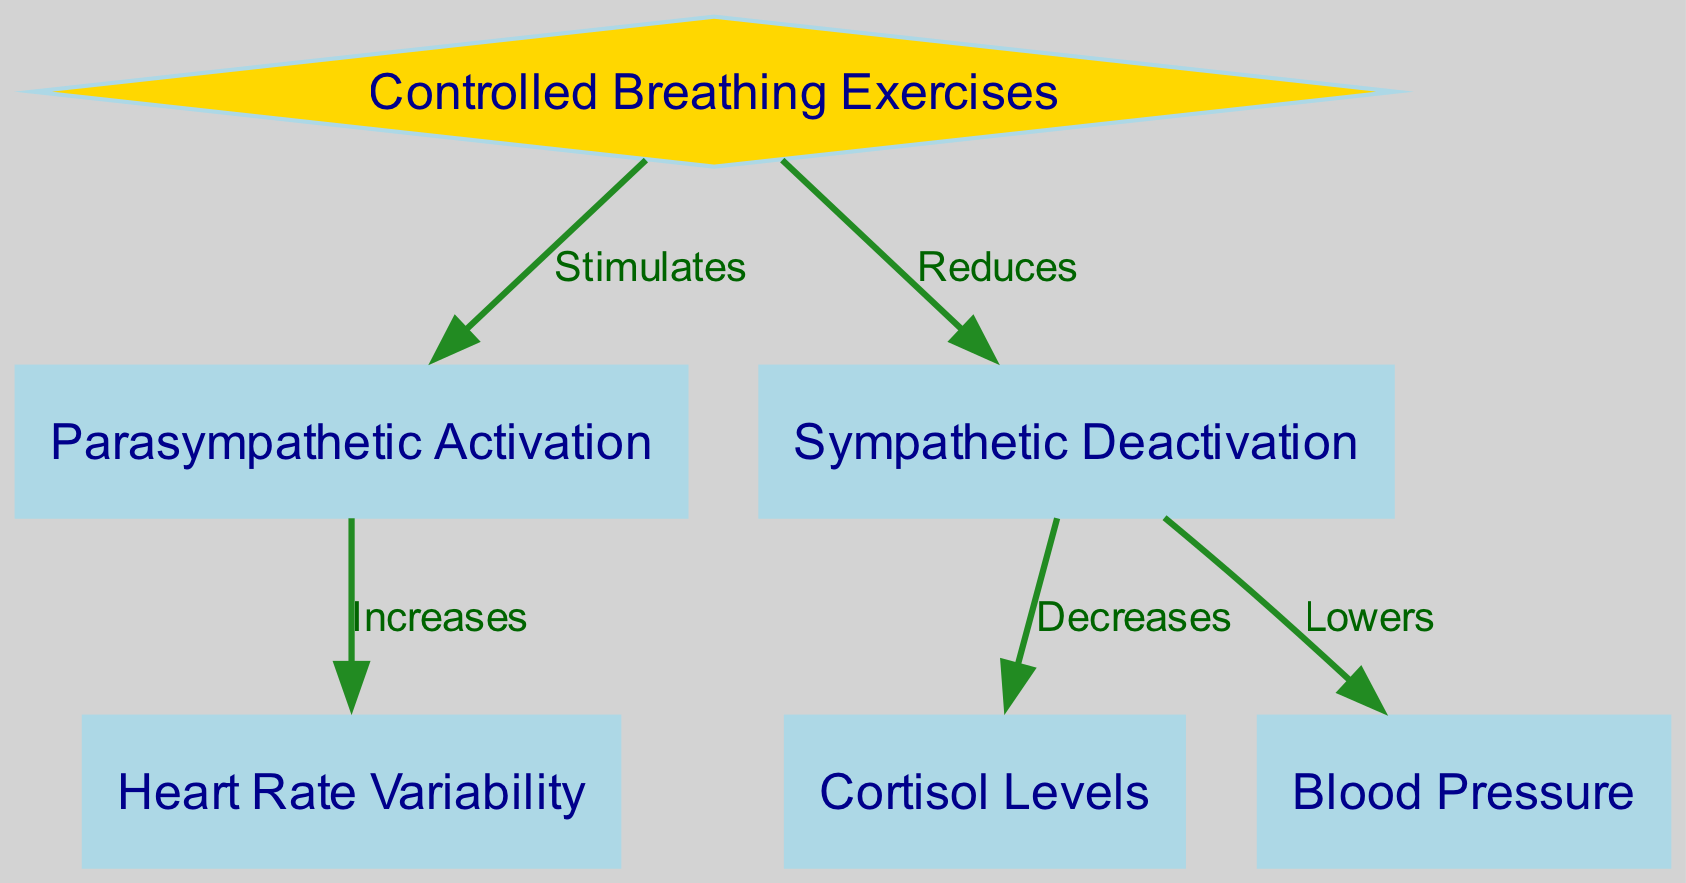What is the main activity represented in the diagram? The diagram focuses on "Controlled Breathing Exercises," which is the only node highlighted as a diamond at the top, indicating the central theme of the diagram.
Answer: Controlled Breathing Exercises How many nodes are shown in the diagram? By counting the number of unique nodes presented in the diagram, we identify six: Controlled Breathing Exercises, Parasympathetic Activation, Sympathetic Deactivation, Heart Rate Variability, Cortisol Levels, and Blood Pressure.
Answer: Six What effect do Controlled Breathing Exercises have on Parasympathetic Activation? The diagram states that Controlled Breathing Exercises "Stimulates" Parasympathetic Activation. This directional relationship is shown with an edge connected to the corresponding nodes.
Answer: Stimulates Which node is connected to Sympathetic Deactivation, and what impact does it indicate? The diagram indicates that Sympathetic Deactivation is connected to Cortisol Levels and Blood Pressure with the labels "Decreases" and "Lowers," respectively. To answer which specific node connects, we see that Sympathetic Deactivation affects both.
Answer: Cortisol Levels and Blood Pressure What happens to Heart Rate Variability when Parasympathetic Activation occurs? The connection shows that Parasympathetic Activation "Increases" Heart Rate Variability, indicating a positive relationship between these two nodes. The label on the edge confirms this increase.
Answer: Increases How does Controlled Breathing impact Sympathetic Activity? Controlled Breathing Exercises directly "Reduces" Sympathetic Deactivation, as indicated by the edge in the diagram. This establishes a clear inverse relationship where breathing exercises lessen sympathetic activity.
Answer: Reduces What happens to cortisol levels due to the effects of Controlled Breathing Exercises? By tracing the edges, Controlled Breathing Exercises lead to the reduction of Sympathetic Deactivation that subsequently results in "Decreases" in Cortisol Levels. The path to follow is first from Controlled Breathing to Sympathetic Deactivation, then to Cortisol Levels.
Answer: Decreases What is the relationship between Blood Pressure and Sympathetic Deactivation? The diagram clearly illustrates that Sympathetic Deactivation "Lowers" Blood Pressure, providing a clear directional influence of sympathetic activity on blood pressure levels.
Answer: Lowers 